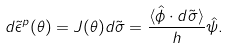Convert formula to latex. <formula><loc_0><loc_0><loc_500><loc_500>d \tilde { \epsilon } ^ { p } ( \theta ) = J ( \theta ) d \tilde { \sigma } = \frac { \langle \hat { \phi } \cdot d \tilde { \sigma } \rangle } { h } \hat { \psi } .</formula> 